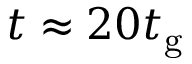<formula> <loc_0><loc_0><loc_500><loc_500>t \approx 2 0 t _ { g }</formula> 